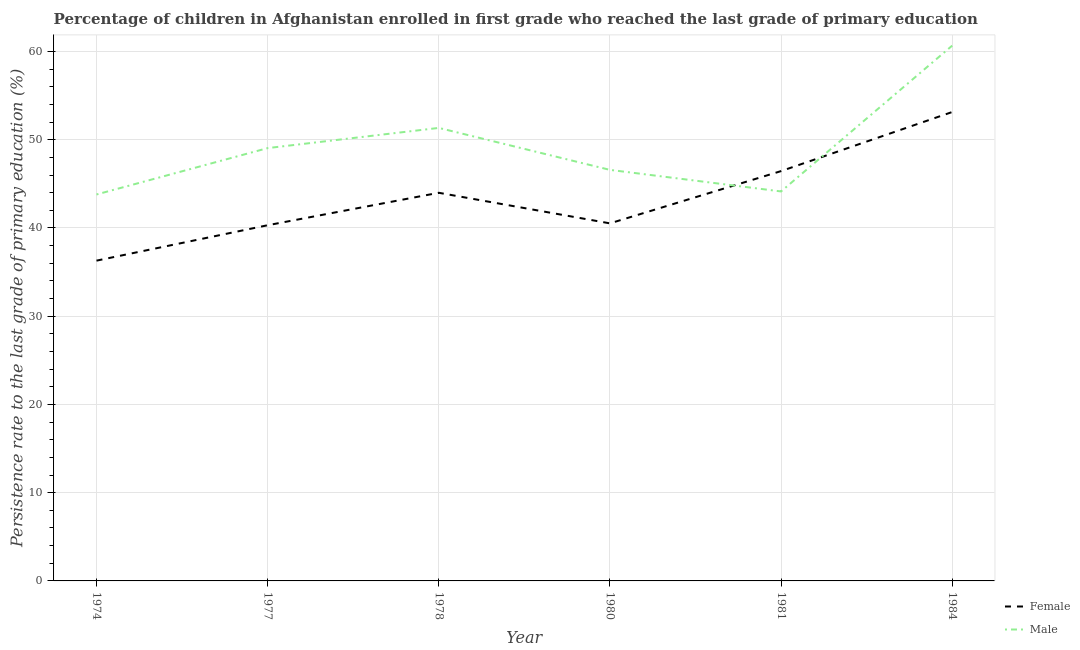How many different coloured lines are there?
Your answer should be very brief. 2. Does the line corresponding to persistence rate of female students intersect with the line corresponding to persistence rate of male students?
Your response must be concise. Yes. Is the number of lines equal to the number of legend labels?
Your answer should be very brief. Yes. What is the persistence rate of female students in 1974?
Your answer should be very brief. 36.3. Across all years, what is the maximum persistence rate of male students?
Provide a succinct answer. 60.66. Across all years, what is the minimum persistence rate of male students?
Your answer should be compact. 43.79. In which year was the persistence rate of male students minimum?
Your answer should be very brief. 1974. What is the total persistence rate of male students in the graph?
Your response must be concise. 295.56. What is the difference between the persistence rate of male students in 1977 and that in 1984?
Keep it short and to the point. -11.61. What is the difference between the persistence rate of female students in 1974 and the persistence rate of male students in 1984?
Your answer should be very brief. -24.37. What is the average persistence rate of male students per year?
Give a very brief answer. 49.26. In the year 1980, what is the difference between the persistence rate of female students and persistence rate of male students?
Offer a terse response. -6.06. What is the ratio of the persistence rate of male students in 1978 to that in 1981?
Your answer should be compact. 1.16. Is the persistence rate of female students in 1974 less than that in 1977?
Your answer should be very brief. Yes. Is the difference between the persistence rate of male students in 1974 and 1981 greater than the difference between the persistence rate of female students in 1974 and 1981?
Give a very brief answer. Yes. What is the difference between the highest and the second highest persistence rate of male students?
Your answer should be compact. 9.32. What is the difference between the highest and the lowest persistence rate of female students?
Ensure brevity in your answer.  16.84. In how many years, is the persistence rate of female students greater than the average persistence rate of female students taken over all years?
Offer a very short reply. 3. How many lines are there?
Your answer should be very brief. 2. How many years are there in the graph?
Your response must be concise. 6. Does the graph contain any zero values?
Your answer should be very brief. No. Does the graph contain grids?
Ensure brevity in your answer.  Yes. Where does the legend appear in the graph?
Give a very brief answer. Bottom right. What is the title of the graph?
Provide a short and direct response. Percentage of children in Afghanistan enrolled in first grade who reached the last grade of primary education. What is the label or title of the Y-axis?
Offer a very short reply. Persistence rate to the last grade of primary education (%). What is the Persistence rate to the last grade of primary education (%) in Female in 1974?
Offer a terse response. 36.3. What is the Persistence rate to the last grade of primary education (%) in Male in 1974?
Offer a very short reply. 43.79. What is the Persistence rate to the last grade of primary education (%) in Female in 1977?
Ensure brevity in your answer.  40.31. What is the Persistence rate to the last grade of primary education (%) in Male in 1977?
Your response must be concise. 49.05. What is the Persistence rate to the last grade of primary education (%) of Female in 1978?
Ensure brevity in your answer.  43.99. What is the Persistence rate to the last grade of primary education (%) of Male in 1978?
Your answer should be very brief. 51.34. What is the Persistence rate to the last grade of primary education (%) in Female in 1980?
Your answer should be very brief. 40.52. What is the Persistence rate to the last grade of primary education (%) of Male in 1980?
Your response must be concise. 46.58. What is the Persistence rate to the last grade of primary education (%) in Female in 1981?
Ensure brevity in your answer.  46.44. What is the Persistence rate to the last grade of primary education (%) of Male in 1981?
Offer a terse response. 44.14. What is the Persistence rate to the last grade of primary education (%) in Female in 1984?
Ensure brevity in your answer.  53.14. What is the Persistence rate to the last grade of primary education (%) of Male in 1984?
Provide a succinct answer. 60.66. Across all years, what is the maximum Persistence rate to the last grade of primary education (%) of Female?
Keep it short and to the point. 53.14. Across all years, what is the maximum Persistence rate to the last grade of primary education (%) in Male?
Make the answer very short. 60.66. Across all years, what is the minimum Persistence rate to the last grade of primary education (%) in Female?
Keep it short and to the point. 36.3. Across all years, what is the minimum Persistence rate to the last grade of primary education (%) in Male?
Your answer should be compact. 43.79. What is the total Persistence rate to the last grade of primary education (%) of Female in the graph?
Provide a succinct answer. 260.69. What is the total Persistence rate to the last grade of primary education (%) in Male in the graph?
Ensure brevity in your answer.  295.56. What is the difference between the Persistence rate to the last grade of primary education (%) of Female in 1974 and that in 1977?
Your answer should be compact. -4.01. What is the difference between the Persistence rate to the last grade of primary education (%) in Male in 1974 and that in 1977?
Give a very brief answer. -5.25. What is the difference between the Persistence rate to the last grade of primary education (%) of Female in 1974 and that in 1978?
Your answer should be compact. -7.69. What is the difference between the Persistence rate to the last grade of primary education (%) of Male in 1974 and that in 1978?
Ensure brevity in your answer.  -7.54. What is the difference between the Persistence rate to the last grade of primary education (%) of Female in 1974 and that in 1980?
Ensure brevity in your answer.  -4.23. What is the difference between the Persistence rate to the last grade of primary education (%) of Male in 1974 and that in 1980?
Keep it short and to the point. -2.79. What is the difference between the Persistence rate to the last grade of primary education (%) of Female in 1974 and that in 1981?
Make the answer very short. -10.15. What is the difference between the Persistence rate to the last grade of primary education (%) in Male in 1974 and that in 1981?
Provide a succinct answer. -0.34. What is the difference between the Persistence rate to the last grade of primary education (%) in Female in 1974 and that in 1984?
Offer a terse response. -16.84. What is the difference between the Persistence rate to the last grade of primary education (%) of Male in 1974 and that in 1984?
Provide a short and direct response. -16.87. What is the difference between the Persistence rate to the last grade of primary education (%) of Female in 1977 and that in 1978?
Offer a very short reply. -3.68. What is the difference between the Persistence rate to the last grade of primary education (%) of Male in 1977 and that in 1978?
Provide a short and direct response. -2.29. What is the difference between the Persistence rate to the last grade of primary education (%) of Female in 1977 and that in 1980?
Provide a short and direct response. -0.21. What is the difference between the Persistence rate to the last grade of primary education (%) of Male in 1977 and that in 1980?
Keep it short and to the point. 2.47. What is the difference between the Persistence rate to the last grade of primary education (%) of Female in 1977 and that in 1981?
Offer a terse response. -6.13. What is the difference between the Persistence rate to the last grade of primary education (%) of Male in 1977 and that in 1981?
Provide a short and direct response. 4.91. What is the difference between the Persistence rate to the last grade of primary education (%) in Female in 1977 and that in 1984?
Your answer should be very brief. -12.83. What is the difference between the Persistence rate to the last grade of primary education (%) of Male in 1977 and that in 1984?
Provide a succinct answer. -11.61. What is the difference between the Persistence rate to the last grade of primary education (%) of Female in 1978 and that in 1980?
Your response must be concise. 3.47. What is the difference between the Persistence rate to the last grade of primary education (%) of Male in 1978 and that in 1980?
Provide a succinct answer. 4.76. What is the difference between the Persistence rate to the last grade of primary education (%) in Female in 1978 and that in 1981?
Offer a terse response. -2.46. What is the difference between the Persistence rate to the last grade of primary education (%) of Male in 1978 and that in 1981?
Give a very brief answer. 7.2. What is the difference between the Persistence rate to the last grade of primary education (%) of Female in 1978 and that in 1984?
Ensure brevity in your answer.  -9.15. What is the difference between the Persistence rate to the last grade of primary education (%) of Male in 1978 and that in 1984?
Ensure brevity in your answer.  -9.32. What is the difference between the Persistence rate to the last grade of primary education (%) of Female in 1980 and that in 1981?
Make the answer very short. -5.92. What is the difference between the Persistence rate to the last grade of primary education (%) in Male in 1980 and that in 1981?
Your answer should be compact. 2.44. What is the difference between the Persistence rate to the last grade of primary education (%) of Female in 1980 and that in 1984?
Provide a short and direct response. -12.62. What is the difference between the Persistence rate to the last grade of primary education (%) in Male in 1980 and that in 1984?
Provide a succinct answer. -14.08. What is the difference between the Persistence rate to the last grade of primary education (%) in Female in 1981 and that in 1984?
Provide a succinct answer. -6.7. What is the difference between the Persistence rate to the last grade of primary education (%) of Male in 1981 and that in 1984?
Provide a succinct answer. -16.52. What is the difference between the Persistence rate to the last grade of primary education (%) of Female in 1974 and the Persistence rate to the last grade of primary education (%) of Male in 1977?
Offer a very short reply. -12.75. What is the difference between the Persistence rate to the last grade of primary education (%) in Female in 1974 and the Persistence rate to the last grade of primary education (%) in Male in 1978?
Keep it short and to the point. -15.04. What is the difference between the Persistence rate to the last grade of primary education (%) of Female in 1974 and the Persistence rate to the last grade of primary education (%) of Male in 1980?
Provide a short and direct response. -10.29. What is the difference between the Persistence rate to the last grade of primary education (%) of Female in 1974 and the Persistence rate to the last grade of primary education (%) of Male in 1981?
Your answer should be very brief. -7.84. What is the difference between the Persistence rate to the last grade of primary education (%) in Female in 1974 and the Persistence rate to the last grade of primary education (%) in Male in 1984?
Give a very brief answer. -24.37. What is the difference between the Persistence rate to the last grade of primary education (%) of Female in 1977 and the Persistence rate to the last grade of primary education (%) of Male in 1978?
Provide a succinct answer. -11.03. What is the difference between the Persistence rate to the last grade of primary education (%) of Female in 1977 and the Persistence rate to the last grade of primary education (%) of Male in 1980?
Ensure brevity in your answer.  -6.27. What is the difference between the Persistence rate to the last grade of primary education (%) in Female in 1977 and the Persistence rate to the last grade of primary education (%) in Male in 1981?
Ensure brevity in your answer.  -3.83. What is the difference between the Persistence rate to the last grade of primary education (%) of Female in 1977 and the Persistence rate to the last grade of primary education (%) of Male in 1984?
Your response must be concise. -20.35. What is the difference between the Persistence rate to the last grade of primary education (%) of Female in 1978 and the Persistence rate to the last grade of primary education (%) of Male in 1980?
Your answer should be very brief. -2.6. What is the difference between the Persistence rate to the last grade of primary education (%) of Female in 1978 and the Persistence rate to the last grade of primary education (%) of Male in 1981?
Your answer should be compact. -0.15. What is the difference between the Persistence rate to the last grade of primary education (%) of Female in 1978 and the Persistence rate to the last grade of primary education (%) of Male in 1984?
Offer a terse response. -16.68. What is the difference between the Persistence rate to the last grade of primary education (%) in Female in 1980 and the Persistence rate to the last grade of primary education (%) in Male in 1981?
Offer a terse response. -3.62. What is the difference between the Persistence rate to the last grade of primary education (%) of Female in 1980 and the Persistence rate to the last grade of primary education (%) of Male in 1984?
Make the answer very short. -20.14. What is the difference between the Persistence rate to the last grade of primary education (%) in Female in 1981 and the Persistence rate to the last grade of primary education (%) in Male in 1984?
Make the answer very short. -14.22. What is the average Persistence rate to the last grade of primary education (%) of Female per year?
Make the answer very short. 43.45. What is the average Persistence rate to the last grade of primary education (%) of Male per year?
Make the answer very short. 49.26. In the year 1974, what is the difference between the Persistence rate to the last grade of primary education (%) in Female and Persistence rate to the last grade of primary education (%) in Male?
Your answer should be very brief. -7.5. In the year 1977, what is the difference between the Persistence rate to the last grade of primary education (%) in Female and Persistence rate to the last grade of primary education (%) in Male?
Give a very brief answer. -8.74. In the year 1978, what is the difference between the Persistence rate to the last grade of primary education (%) in Female and Persistence rate to the last grade of primary education (%) in Male?
Give a very brief answer. -7.35. In the year 1980, what is the difference between the Persistence rate to the last grade of primary education (%) of Female and Persistence rate to the last grade of primary education (%) of Male?
Provide a short and direct response. -6.06. In the year 1981, what is the difference between the Persistence rate to the last grade of primary education (%) of Female and Persistence rate to the last grade of primary education (%) of Male?
Your answer should be compact. 2.3. In the year 1984, what is the difference between the Persistence rate to the last grade of primary education (%) in Female and Persistence rate to the last grade of primary education (%) in Male?
Your answer should be compact. -7.52. What is the ratio of the Persistence rate to the last grade of primary education (%) in Female in 1974 to that in 1977?
Give a very brief answer. 0.9. What is the ratio of the Persistence rate to the last grade of primary education (%) of Male in 1974 to that in 1977?
Make the answer very short. 0.89. What is the ratio of the Persistence rate to the last grade of primary education (%) of Female in 1974 to that in 1978?
Your answer should be very brief. 0.83. What is the ratio of the Persistence rate to the last grade of primary education (%) in Male in 1974 to that in 1978?
Offer a very short reply. 0.85. What is the ratio of the Persistence rate to the last grade of primary education (%) of Female in 1974 to that in 1980?
Offer a very short reply. 0.9. What is the ratio of the Persistence rate to the last grade of primary education (%) of Male in 1974 to that in 1980?
Give a very brief answer. 0.94. What is the ratio of the Persistence rate to the last grade of primary education (%) of Female in 1974 to that in 1981?
Offer a terse response. 0.78. What is the ratio of the Persistence rate to the last grade of primary education (%) of Female in 1974 to that in 1984?
Offer a very short reply. 0.68. What is the ratio of the Persistence rate to the last grade of primary education (%) of Male in 1974 to that in 1984?
Keep it short and to the point. 0.72. What is the ratio of the Persistence rate to the last grade of primary education (%) of Female in 1977 to that in 1978?
Your answer should be compact. 0.92. What is the ratio of the Persistence rate to the last grade of primary education (%) in Male in 1977 to that in 1978?
Provide a short and direct response. 0.96. What is the ratio of the Persistence rate to the last grade of primary education (%) in Male in 1977 to that in 1980?
Offer a very short reply. 1.05. What is the ratio of the Persistence rate to the last grade of primary education (%) in Female in 1977 to that in 1981?
Offer a very short reply. 0.87. What is the ratio of the Persistence rate to the last grade of primary education (%) of Male in 1977 to that in 1981?
Offer a terse response. 1.11. What is the ratio of the Persistence rate to the last grade of primary education (%) in Female in 1977 to that in 1984?
Make the answer very short. 0.76. What is the ratio of the Persistence rate to the last grade of primary education (%) in Male in 1977 to that in 1984?
Offer a very short reply. 0.81. What is the ratio of the Persistence rate to the last grade of primary education (%) of Female in 1978 to that in 1980?
Provide a short and direct response. 1.09. What is the ratio of the Persistence rate to the last grade of primary education (%) in Male in 1978 to that in 1980?
Provide a succinct answer. 1.1. What is the ratio of the Persistence rate to the last grade of primary education (%) in Female in 1978 to that in 1981?
Provide a short and direct response. 0.95. What is the ratio of the Persistence rate to the last grade of primary education (%) of Male in 1978 to that in 1981?
Keep it short and to the point. 1.16. What is the ratio of the Persistence rate to the last grade of primary education (%) in Female in 1978 to that in 1984?
Offer a terse response. 0.83. What is the ratio of the Persistence rate to the last grade of primary education (%) in Male in 1978 to that in 1984?
Offer a very short reply. 0.85. What is the ratio of the Persistence rate to the last grade of primary education (%) in Female in 1980 to that in 1981?
Offer a terse response. 0.87. What is the ratio of the Persistence rate to the last grade of primary education (%) of Male in 1980 to that in 1981?
Ensure brevity in your answer.  1.06. What is the ratio of the Persistence rate to the last grade of primary education (%) in Female in 1980 to that in 1984?
Your response must be concise. 0.76. What is the ratio of the Persistence rate to the last grade of primary education (%) in Male in 1980 to that in 1984?
Your answer should be compact. 0.77. What is the ratio of the Persistence rate to the last grade of primary education (%) in Female in 1981 to that in 1984?
Keep it short and to the point. 0.87. What is the ratio of the Persistence rate to the last grade of primary education (%) in Male in 1981 to that in 1984?
Ensure brevity in your answer.  0.73. What is the difference between the highest and the second highest Persistence rate to the last grade of primary education (%) of Female?
Your response must be concise. 6.7. What is the difference between the highest and the second highest Persistence rate to the last grade of primary education (%) in Male?
Provide a succinct answer. 9.32. What is the difference between the highest and the lowest Persistence rate to the last grade of primary education (%) in Female?
Your response must be concise. 16.84. What is the difference between the highest and the lowest Persistence rate to the last grade of primary education (%) of Male?
Make the answer very short. 16.87. 